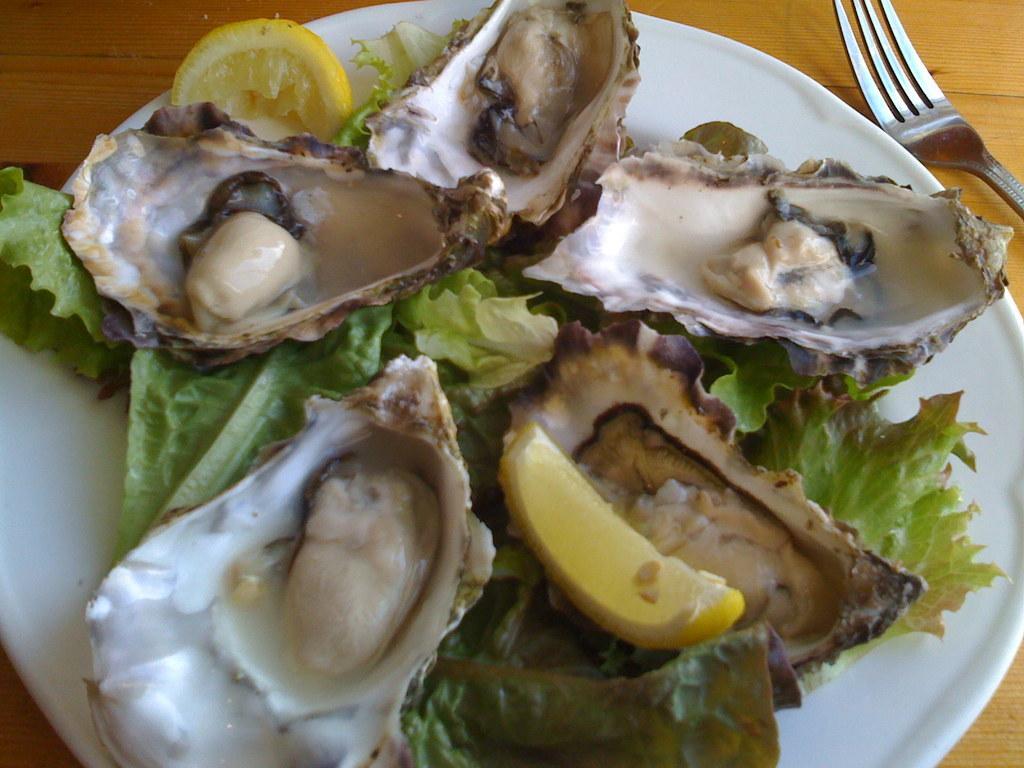Could you give a brief overview of what you see in this image? In the image there is some food item served on a plate and beside the plate there is a fork. 